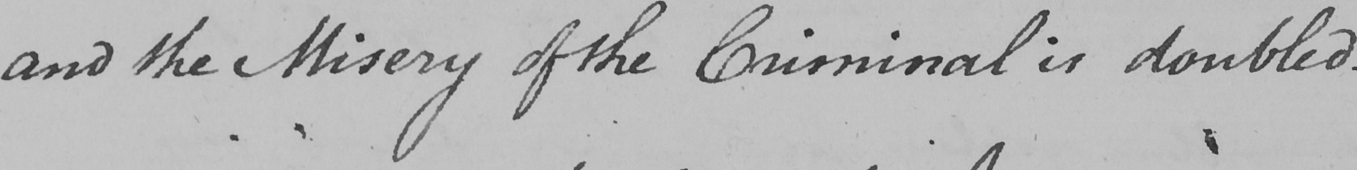What text is written in this handwritten line? and the Misery of the Criminal is doubled . 